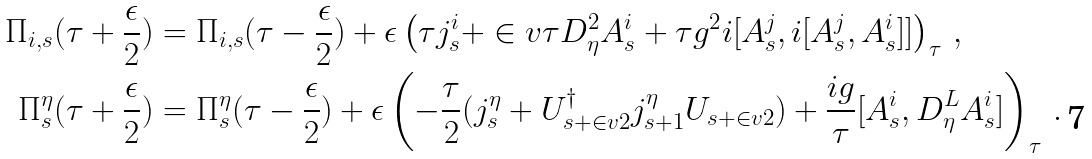<formula> <loc_0><loc_0><loc_500><loc_500>\Pi _ { i , s } ( \tau + \frac { \epsilon } { 2 } ) & = \Pi _ { i , s } ( \tau - \frac { \epsilon } { 2 } ) + \epsilon \left ( \tau j ^ { i } _ { s } + \in v { \tau } D _ { \eta } ^ { 2 } A ^ { i } _ { s } + \tau g ^ { 2 } i [ A ^ { j } _ { s } , i [ A ^ { j } _ { s } , A ^ { i } _ { s } ] ] \right ) _ { \tau } \, , \\ \Pi ^ { \eta } _ { s } ( \tau + \frac { \epsilon } { 2 } ) & = \Pi ^ { \eta } _ { s } ( \tau - \frac { \epsilon } { 2 } ) + \epsilon \left ( - \frac { \tau } { 2 } ( j ^ { \eta } _ { s } + U _ { s + \in v 2 } ^ { \dagger } j ^ { \eta } _ { s + 1 } U _ { s + \in v 2 } ) + \frac { i g } { \tau } [ A ^ { i } _ { s } , D _ { \eta } ^ { L } A ^ { i } _ { s } ] \right ) _ { \tau } \, .</formula> 